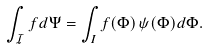Convert formula to latex. <formula><loc_0><loc_0><loc_500><loc_500>\int _ { \mathcal { I } } f d \Psi = \int _ { I } f ( \Phi ) \, \psi ( \Phi ) d \Phi .</formula> 